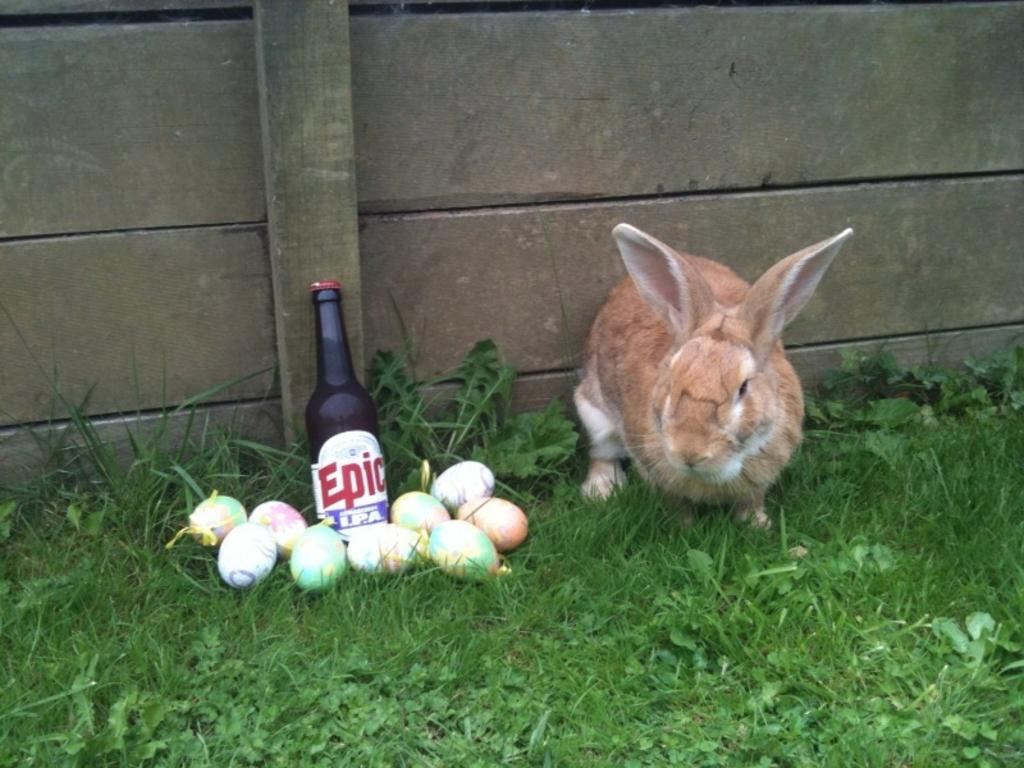What type of animal is in the image? There is a brown color rabbit in the image. Where is the rabbit located? The rabbit is on the ground. What else can be found on the ground in the image? There are eggs and a bottle on the ground. What can be seen in the background of the image? There is a wall in the background of the image. Can you see any snakes slithering in the image? There are no snakes present in the image. Is the ground in the image made of quicksand? The ground in the image is not made of quicksand; it appears to be a solid surface. 